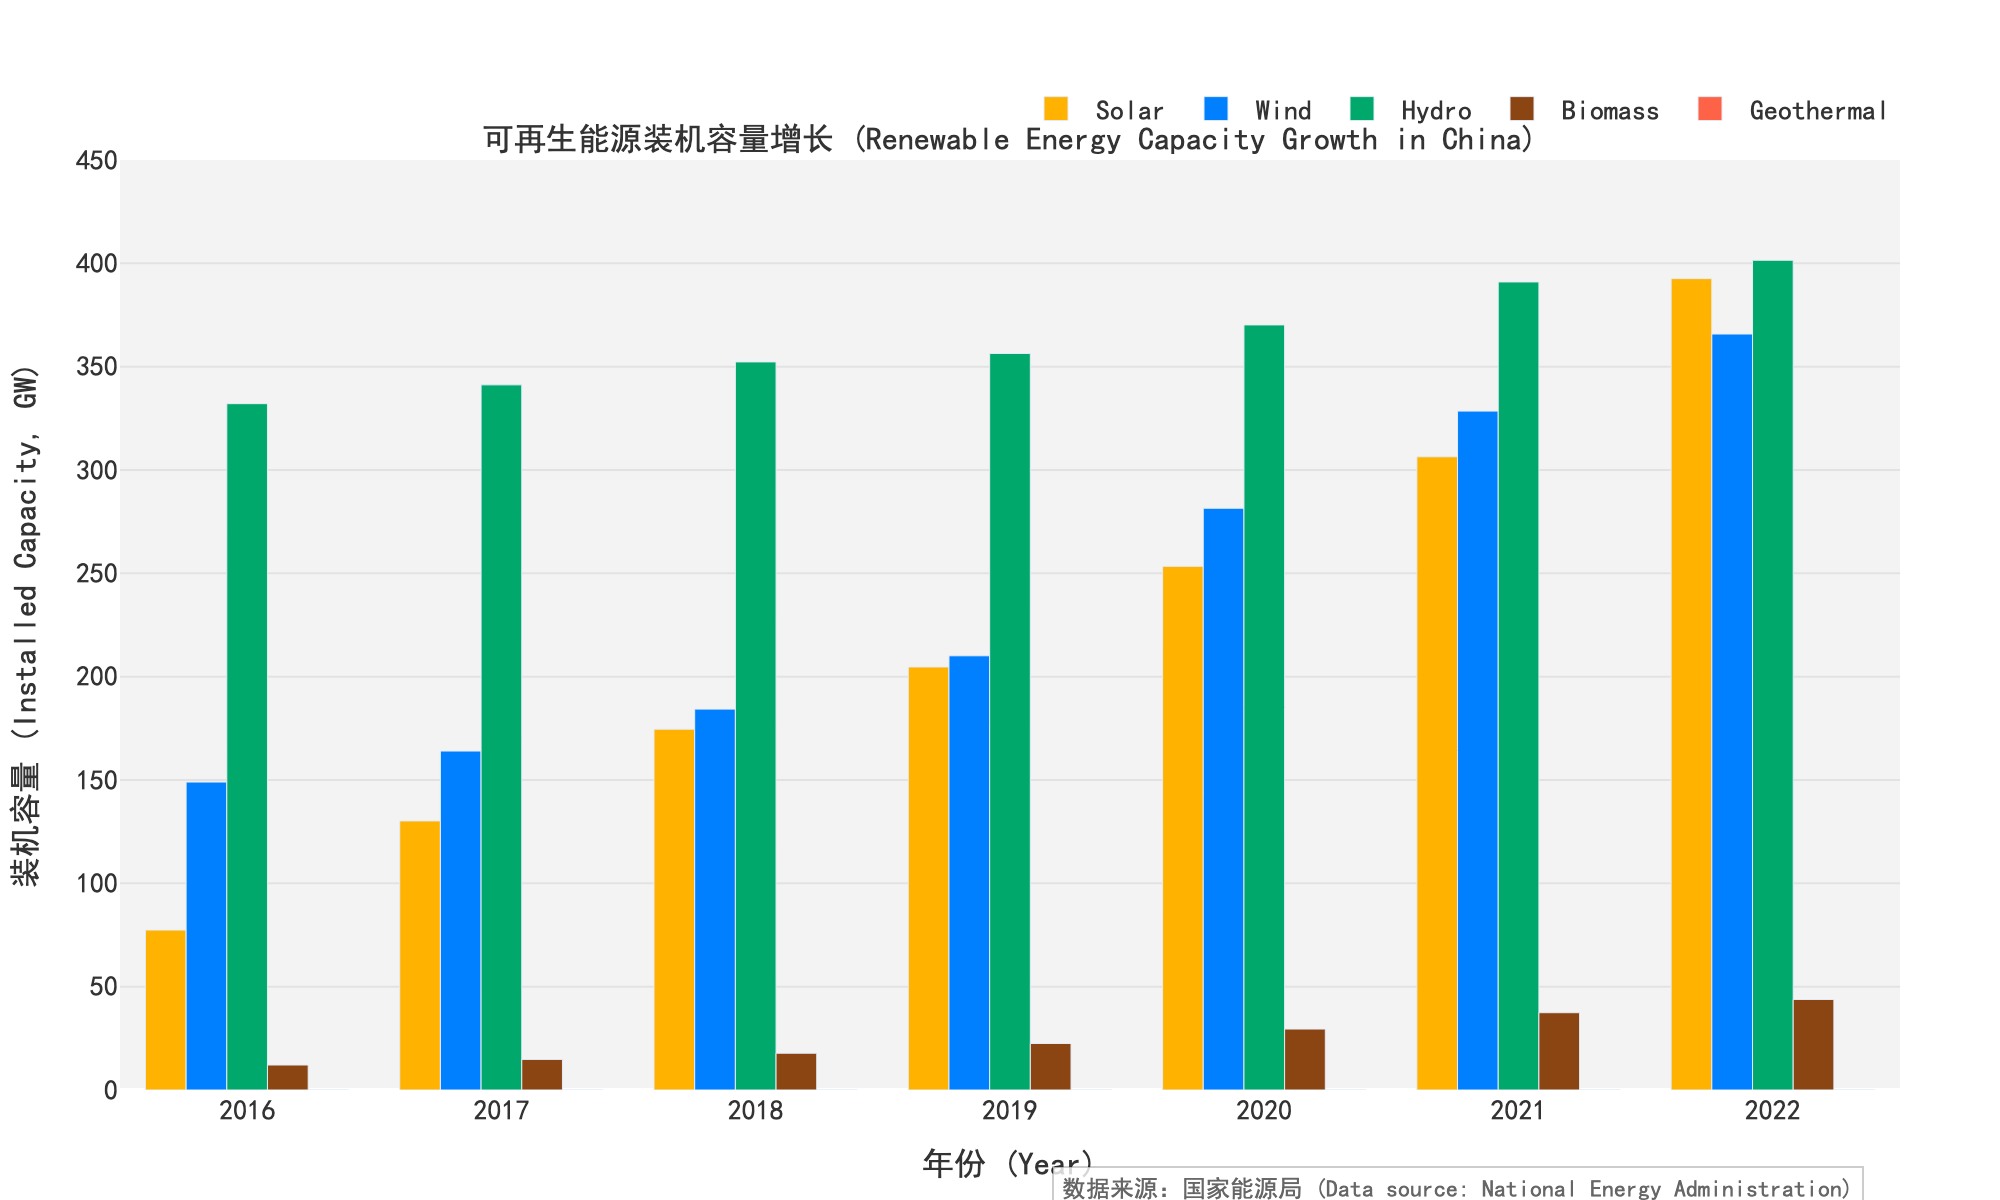What's the difference in solar energy capacity between 2016 and 2022? To find the difference, subtract the solar capacity in 2016 from the solar capacity in 2022: 392.6 - 77.4 = 315.2
Answer: 315.2 GW Which energy source had the highest growth in installed capacity from 2016 to 2022? To determine the highest growth, calculate the differences for each energy source: Solar (392.6 - 77.4 = 315.2), Wind (365.8 - 149.0 = 216.8), Hydro (401.5 - 332.1 = 69.4), Biomass (43.8 - 12.1 = 31.7), Geothermal (0.05 - 0.03 = 0.02). The highest growth is in Solar with 315.2 GW.
Answer: Solar What is the total installed capacity for all energy sources combined in 2020? Sum the capacities for all sources in 2020: Solar (253.4) + Wind (281.5) + Hydro (370.2) + Biomass (29.5) + Geothermal (0.03) = 934.63 GW
Answer: 934.63 GW Between which two consecutive years did wind energy capacity see the highest increase? Calculate the year-over-year increase in wind capacity: 2017-2016 (164.0 - 149.0 = 15.0), 2018-2017 (184.3 - 164.0 = 20.3), 2019-2018 (210.1 - 184.3 = 25.8), 2020-2019 (281.5 - 210.1 = 71.4), 2021-2020 (328.5 - 281.5 = 47.0), 2022-2021 (365.8 - 328.5 = 37.3). The highest increase is between 2019 and 2020.
Answer: 2019 and 2020 What was the percentage increase in biomass energy capacity from 2016 to 2022? Calculate the percentage increase: ((43.8 - 12.1) / 12.1) * 100 = 261.98%
Answer: 261.98% In which year did hydro energy capacity pass 350 GW? Check hydro values by year and identify when it first surpasses 350 GW: 2018 (352.3)
Answer: 2018 Which energy source had almost no growth between 2016 and 2022? Comparing the initial and final values for each source, geothermal shows minimal growth from 0.03 GW to 0.05 GW.
Answer: Geothermal How many years did it take for solar energy capacity to more than double from its 2016 value? Solar capacity in 2016 is 77.4. Doubling this value gives 154.8. Check subsequent years until the value exceeds 154.8. It surpasses in 2018 with 174.6 GW.
Answer: 2 years What's the average annual growth rate of wind energy capacity from 2016 to 2022? Calculate total increase: 365.8 - 149.0 = 216.8 GW. Then divide by the number of years (2022-2016 = 6): 216.8 / 6 = 36.13 GW per year on average.
Answer: 36.13 GW per year 